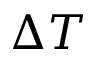Convert formula to latex. <formula><loc_0><loc_0><loc_500><loc_500>\Delta T</formula> 